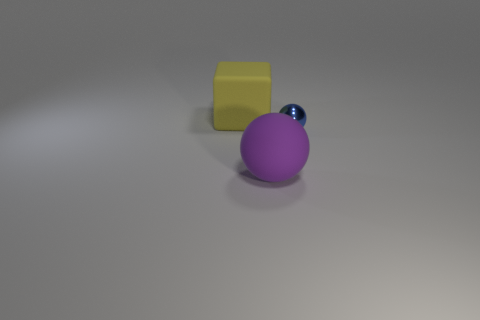Subtract all spheres. How many objects are left? 1 Subtract 0 cyan cylinders. How many objects are left? 3 Subtract all red balls. Subtract all cyan cylinders. How many balls are left? 2 Subtract all red cubes. How many purple spheres are left? 1 Subtract all tiny cyan rubber cubes. Subtract all balls. How many objects are left? 1 Add 2 large things. How many large things are left? 4 Add 1 big rubber things. How many big rubber things exist? 3 Add 1 big rubber blocks. How many objects exist? 4 